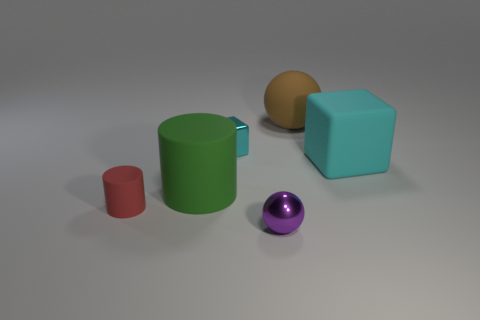Add 3 big green rubber blocks. How many objects exist? 9 Subtract all cylinders. How many objects are left? 4 Subtract all brown matte objects. Subtract all big matte things. How many objects are left? 2 Add 1 tiny metal spheres. How many tiny metal spheres are left? 2 Add 6 large brown matte objects. How many large brown matte objects exist? 7 Subtract 0 yellow cubes. How many objects are left? 6 